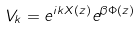<formula> <loc_0><loc_0><loc_500><loc_500>V _ { k } = e ^ { i k X ( z ) } e ^ { \beta \Phi ( z ) }</formula> 